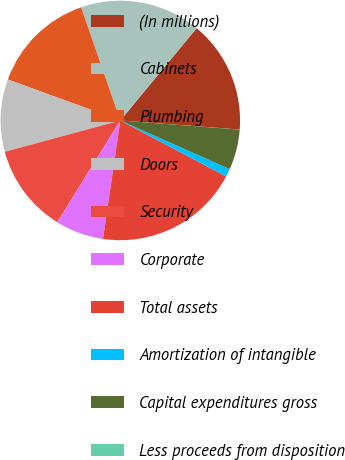Convert chart. <chart><loc_0><loc_0><loc_500><loc_500><pie_chart><fcel>(In millions)<fcel>Cabinets<fcel>Plumbing<fcel>Doors<fcel>Security<fcel>Corporate<fcel>Total assets<fcel>Amortization of intangible<fcel>Capital expenditures gross<fcel>Less proceeds from disposition<nl><fcel>15.21%<fcel>16.3%<fcel>14.13%<fcel>9.78%<fcel>11.95%<fcel>6.52%<fcel>19.56%<fcel>1.09%<fcel>5.44%<fcel>0.01%<nl></chart> 